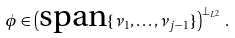<formula> <loc_0><loc_0><loc_500><loc_500>\phi \in \left ( \text {span} \{ \nu _ { 1 } , \dots , \nu _ { j - 1 } \} \right ) ^ { \perp _ { L ^ { 2 } } } \, .</formula> 